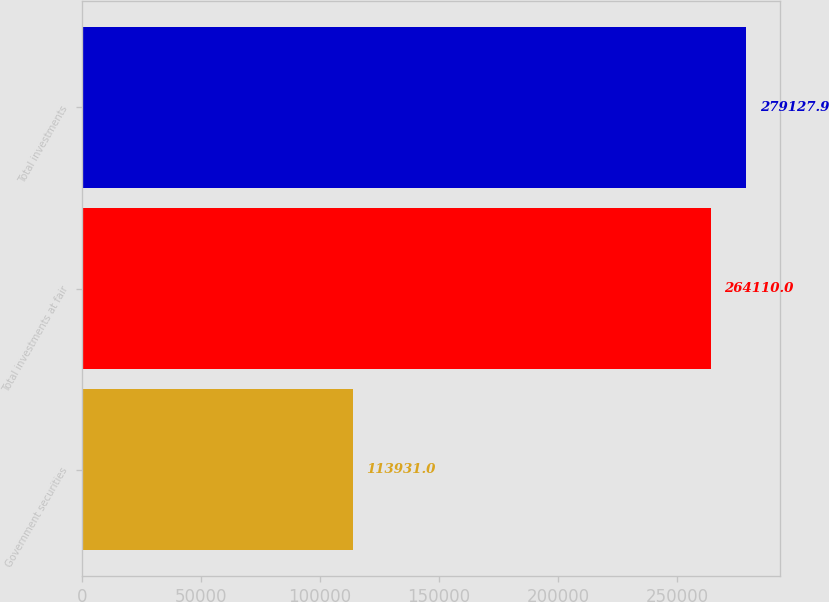<chart> <loc_0><loc_0><loc_500><loc_500><bar_chart><fcel>Government securities<fcel>Total investments at fair<fcel>Total investments<nl><fcel>113931<fcel>264110<fcel>279128<nl></chart> 